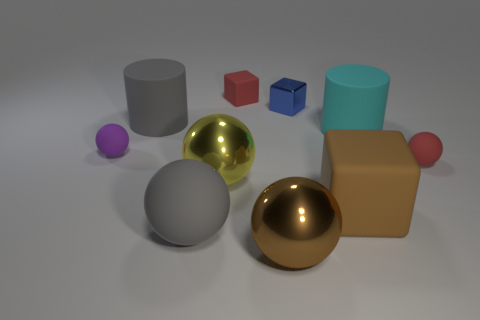How many cyan objects have the same material as the tiny purple object?
Your answer should be compact. 1. There is a yellow thing; is its shape the same as the red matte thing that is right of the small blue shiny thing?
Your answer should be very brief. Yes. Is there a red block in front of the shiny object that is behind the small ball that is on the right side of the tiny purple rubber object?
Your answer should be compact. No. What size is the gray object that is in front of the tiny purple rubber sphere?
Give a very brief answer. Large. There is a brown ball that is the same size as the brown matte thing; what material is it?
Offer a terse response. Metal. Do the purple matte object and the tiny shiny object have the same shape?
Give a very brief answer. No. What number of objects are small blue rubber cylinders or metallic spheres in front of the gray sphere?
Offer a terse response. 1. What is the material of the big ball that is the same color as the large block?
Ensure brevity in your answer.  Metal. There is a matte object behind the metallic block; is its size the same as the tiny blue object?
Provide a succinct answer. Yes. What number of brown balls are in front of the big gray object that is in front of the small object in front of the small purple sphere?
Offer a terse response. 1. 